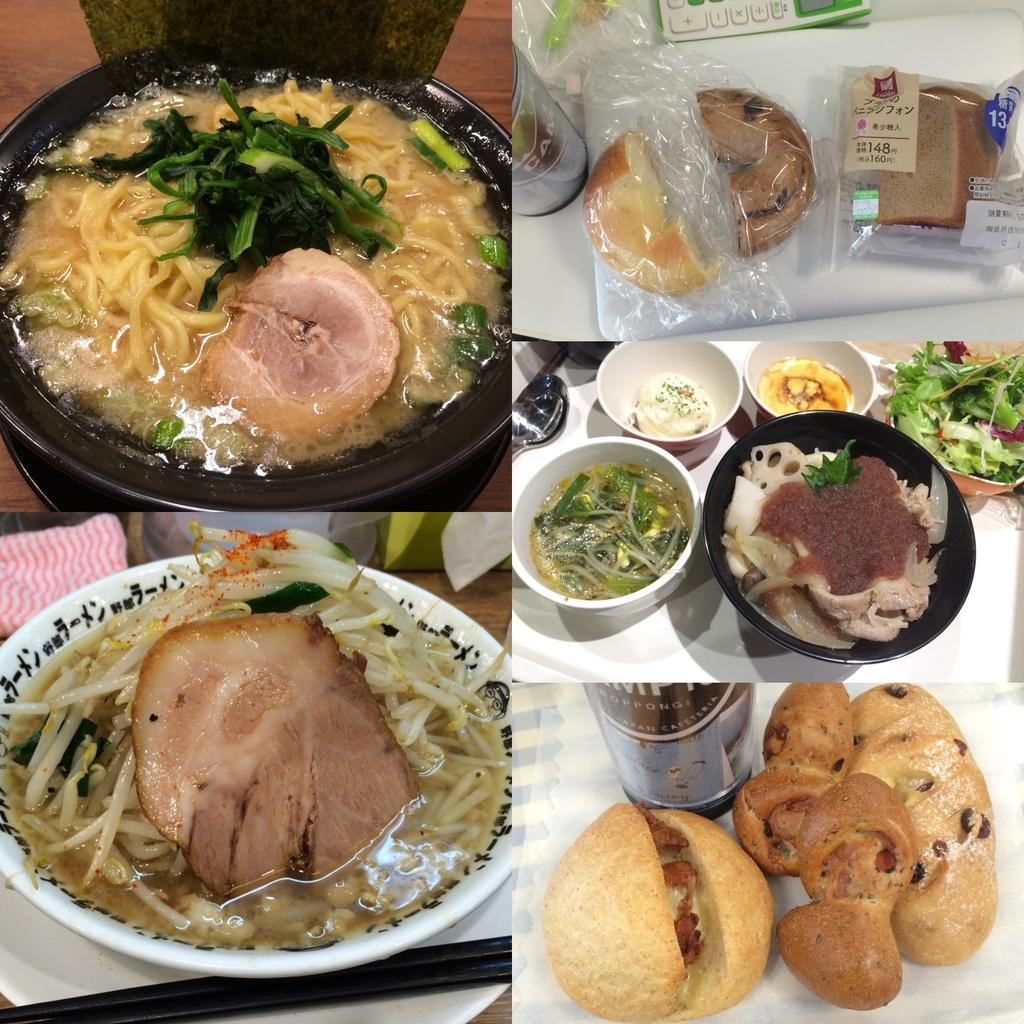What is in the bowl that is visible in the image? There are eatable items in a bowl in the image. Where is the bowl located in the image? The bowl is placed on a table. What type of train can be seen passing by the tree in the image? There is no train or tree present in the image; it only features a bowl of eatable items on a table. 